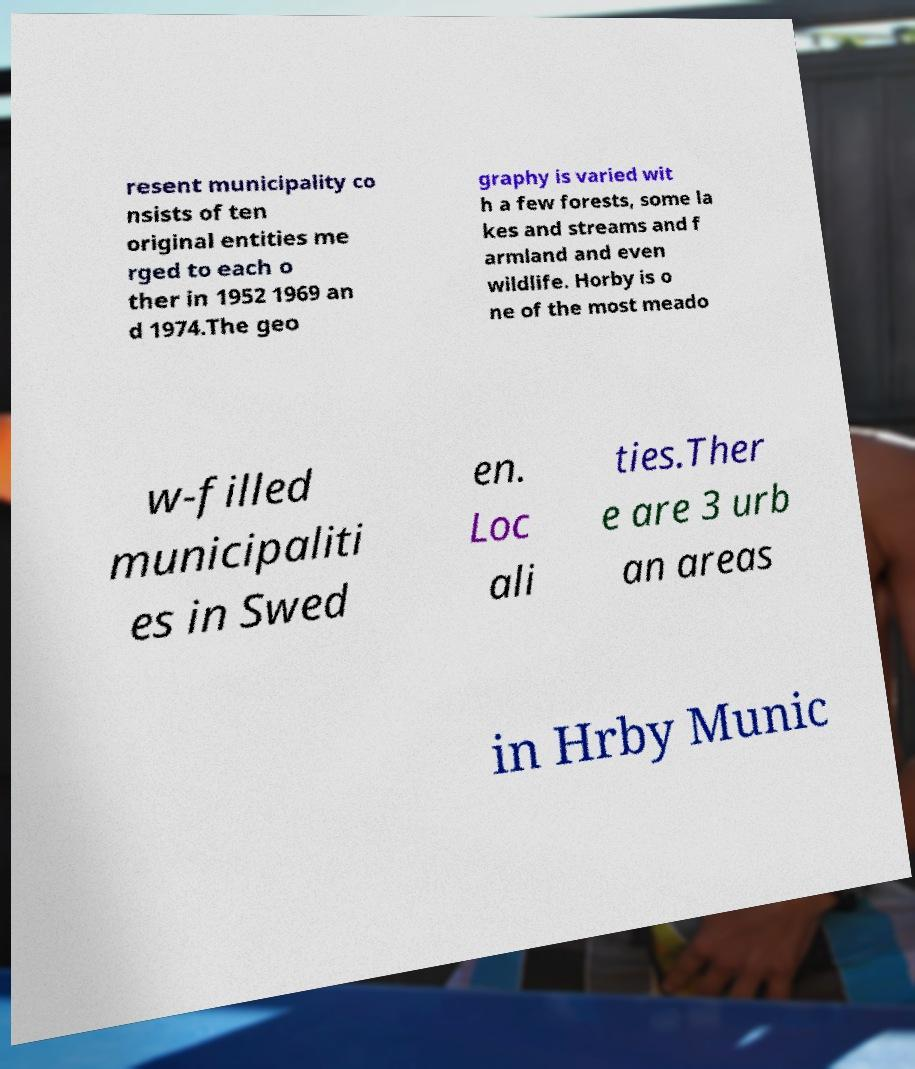What messages or text are displayed in this image? I need them in a readable, typed format. resent municipality co nsists of ten original entities me rged to each o ther in 1952 1969 an d 1974.The geo graphy is varied wit h a few forests, some la kes and streams and f armland and even wildlife. Horby is o ne of the most meado w-filled municipaliti es in Swed en. Loc ali ties.Ther e are 3 urb an areas in Hrby Munic 